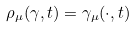Convert formula to latex. <formula><loc_0><loc_0><loc_500><loc_500>\rho _ { \mu } ( \gamma , t ) = \gamma _ { \mu } ( \cdot , t )</formula> 